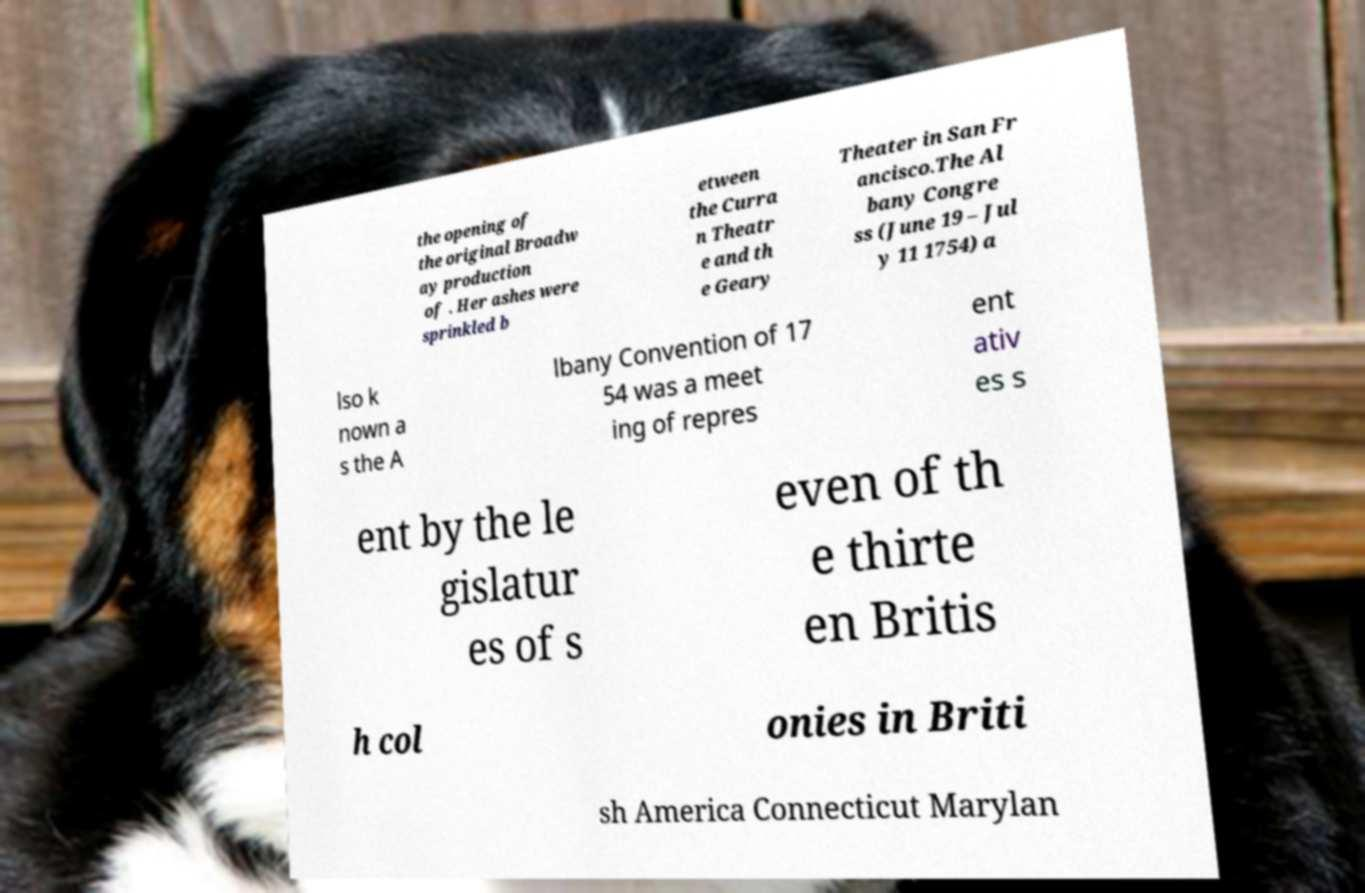Please read and relay the text visible in this image. What does it say? the opening of the original Broadw ay production of . Her ashes were sprinkled b etween the Curra n Theatr e and th e Geary Theater in San Fr ancisco.The Al bany Congre ss (June 19 – Jul y 11 1754) a lso k nown a s the A lbany Convention of 17 54 was a meet ing of repres ent ativ es s ent by the le gislatur es of s even of th e thirte en Britis h col onies in Briti sh America Connecticut Marylan 